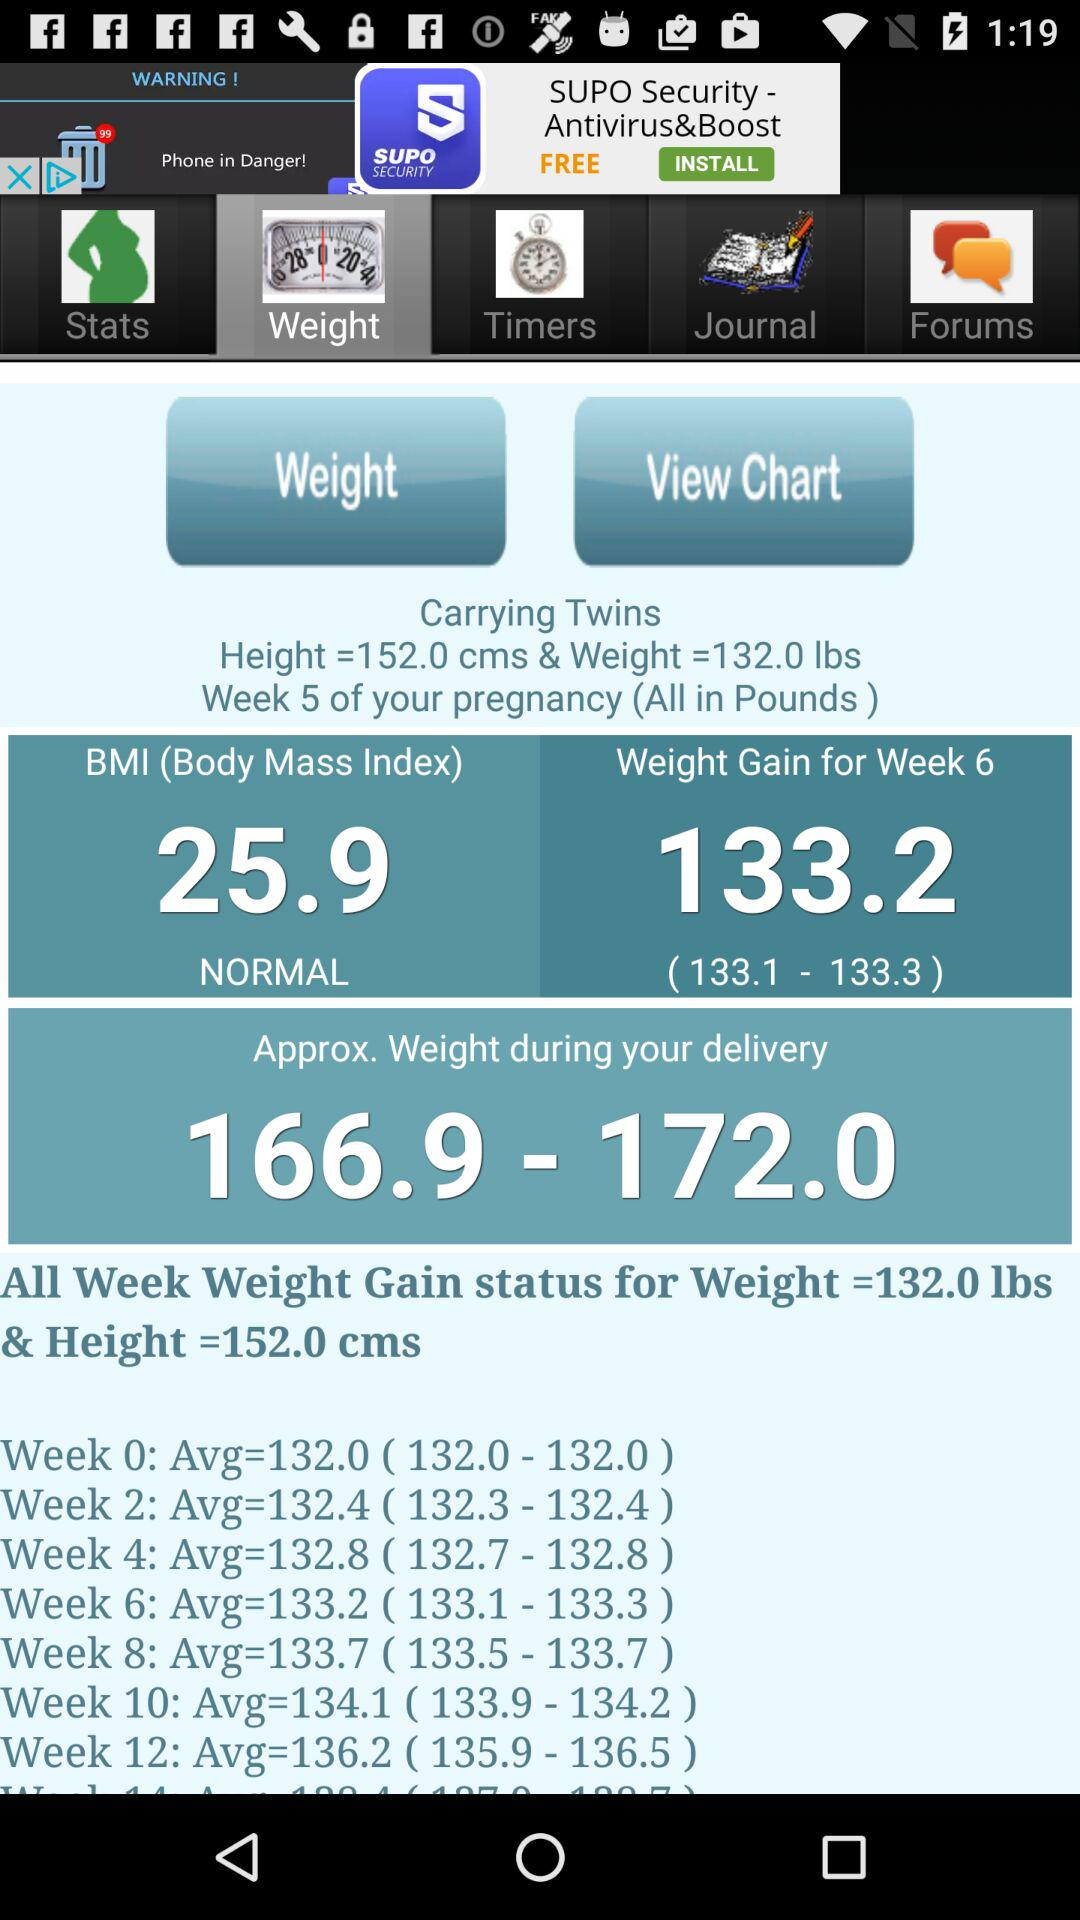Which tab am I on? You are on the "Weight" tab. 